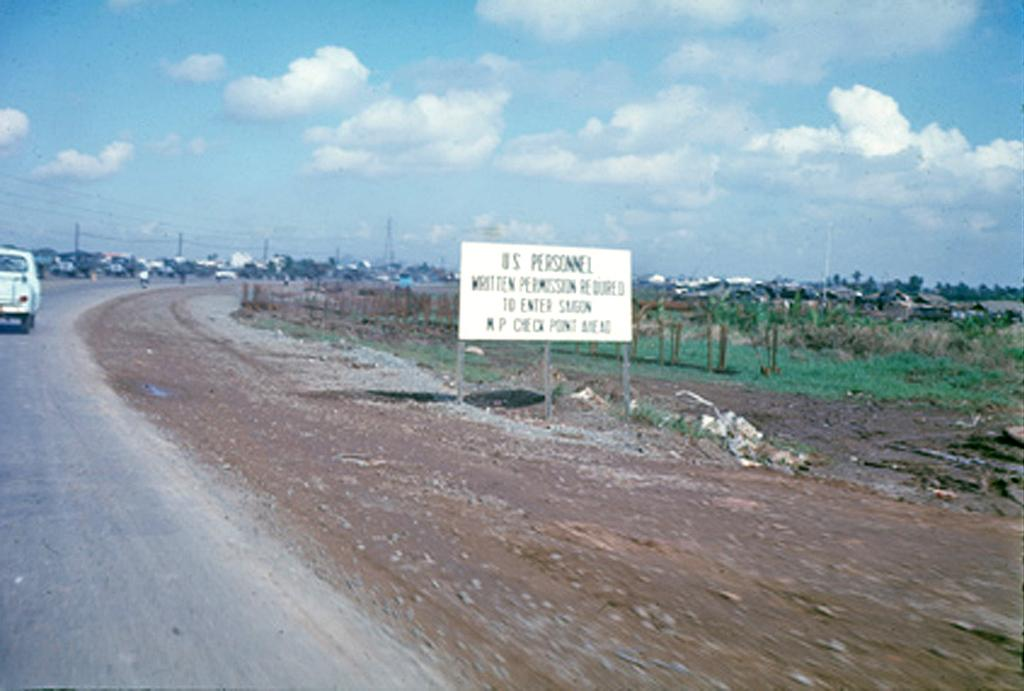What is on the road in the image? There is a vehicle on the road in the image. What can be seen beneath the vehicle? The road is visible in the image. What type of terrain is present in the image? Sand and grass are visible in the image. What structure is present in the image? There is a board in the image. What is supporting the board? A pole is present in the image. What is attached to the pole? Electric wires are visible in the image. What type of vegetation is present in the image? Trees are present in the image. What is visible above the trees? The sky is visible in the image. What is the condition of the sky in the image? The sky appears to be cloudy in the image. How many pages of the book can be seen in the image? There is no book present in the image, so it is not possible to determine the number of pages. --- 